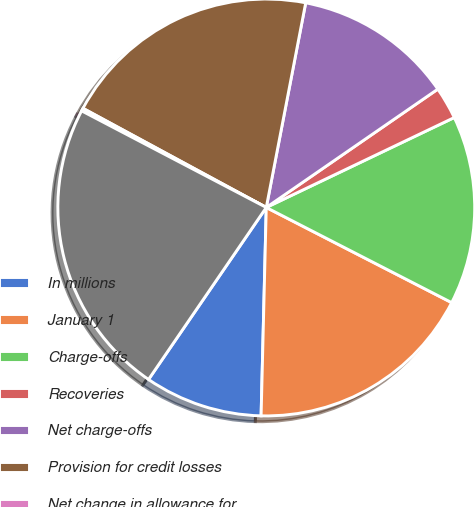<chart> <loc_0><loc_0><loc_500><loc_500><pie_chart><fcel>In millions<fcel>January 1<fcel>Charge-offs<fcel>Recoveries<fcel>Net charge-offs<fcel>Provision for credit losses<fcel>Net change in allowance for<fcel>December 31<nl><fcel>9.16%<fcel>17.85%<fcel>14.65%<fcel>2.51%<fcel>12.36%<fcel>20.14%<fcel>0.22%<fcel>23.12%<nl></chart> 